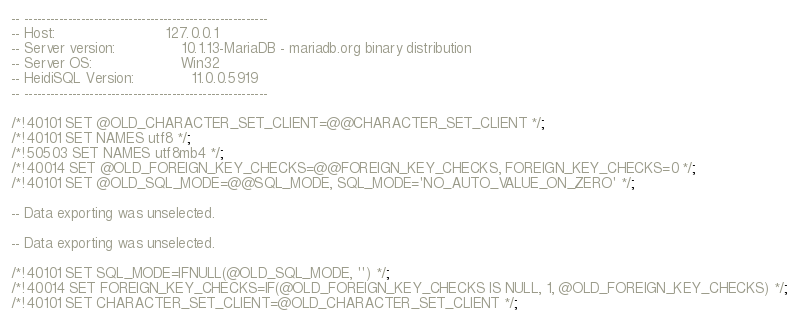Convert code to text. <code><loc_0><loc_0><loc_500><loc_500><_SQL_>-- --------------------------------------------------------
-- Host:                         127.0.0.1
-- Server version:               10.1.13-MariaDB - mariadb.org binary distribution
-- Server OS:                    Win32
-- HeidiSQL Version:             11.0.0.5919
-- --------------------------------------------------------

/*!40101 SET @OLD_CHARACTER_SET_CLIENT=@@CHARACTER_SET_CLIENT */;
/*!40101 SET NAMES utf8 */;
/*!50503 SET NAMES utf8mb4 */;
/*!40014 SET @OLD_FOREIGN_KEY_CHECKS=@@FOREIGN_KEY_CHECKS, FOREIGN_KEY_CHECKS=0 */;
/*!40101 SET @OLD_SQL_MODE=@@SQL_MODE, SQL_MODE='NO_AUTO_VALUE_ON_ZERO' */;

-- Data exporting was unselected.

-- Data exporting was unselected.

/*!40101 SET SQL_MODE=IFNULL(@OLD_SQL_MODE, '') */;
/*!40014 SET FOREIGN_KEY_CHECKS=IF(@OLD_FOREIGN_KEY_CHECKS IS NULL, 1, @OLD_FOREIGN_KEY_CHECKS) */;
/*!40101 SET CHARACTER_SET_CLIENT=@OLD_CHARACTER_SET_CLIENT */;
</code> 